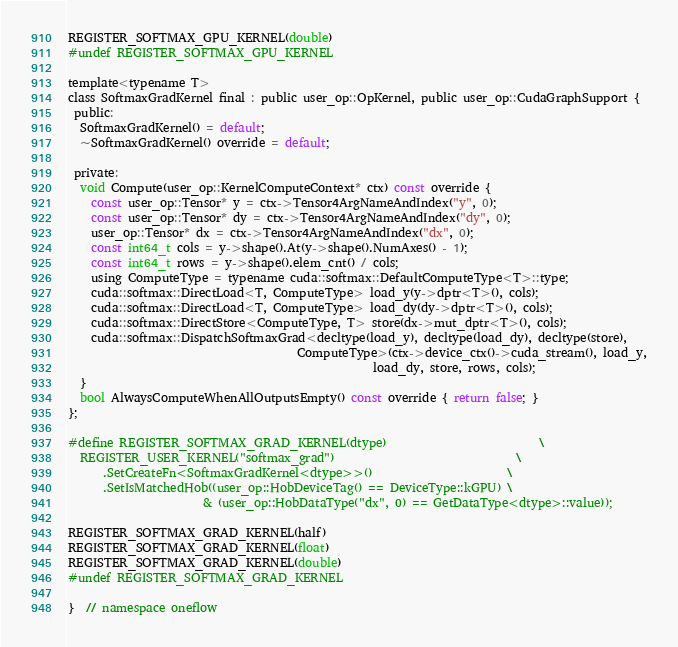Convert code to text. <code><loc_0><loc_0><loc_500><loc_500><_Cuda_>REGISTER_SOFTMAX_GPU_KERNEL(double)
#undef REGISTER_SOFTMAX_GPU_KERNEL

template<typename T>
class SoftmaxGradKernel final : public user_op::OpKernel, public user_op::CudaGraphSupport {
 public:
  SoftmaxGradKernel() = default;
  ~SoftmaxGradKernel() override = default;

 private:
  void Compute(user_op::KernelComputeContext* ctx) const override {
    const user_op::Tensor* y = ctx->Tensor4ArgNameAndIndex("y", 0);
    const user_op::Tensor* dy = ctx->Tensor4ArgNameAndIndex("dy", 0);
    user_op::Tensor* dx = ctx->Tensor4ArgNameAndIndex("dx", 0);
    const int64_t cols = y->shape().At(y->shape().NumAxes() - 1);
    const int64_t rows = y->shape().elem_cnt() / cols;
    using ComputeType = typename cuda::softmax::DefaultComputeType<T>::type;
    cuda::softmax::DirectLoad<T, ComputeType> load_y(y->dptr<T>(), cols);
    cuda::softmax::DirectLoad<T, ComputeType> load_dy(dy->dptr<T>(), cols);
    cuda::softmax::DirectStore<ComputeType, T> store(dx->mut_dptr<T>(), cols);
    cuda::softmax::DispatchSoftmaxGrad<decltype(load_y), decltype(load_dy), decltype(store),
                                       ComputeType>(ctx->device_ctx()->cuda_stream(), load_y,
                                                    load_dy, store, rows, cols);
  }
  bool AlwaysComputeWhenAllOutputsEmpty() const override { return false; }
};

#define REGISTER_SOFTMAX_GRAD_KERNEL(dtype)                          \
  REGISTER_USER_KERNEL("softmax_grad")                               \
      .SetCreateFn<SoftmaxGradKernel<dtype>>()                       \
      .SetIsMatchedHob((user_op::HobDeviceTag() == DeviceType::kGPU) \
                       & (user_op::HobDataType("dx", 0) == GetDataType<dtype>::value));

REGISTER_SOFTMAX_GRAD_KERNEL(half)
REGISTER_SOFTMAX_GRAD_KERNEL(float)
REGISTER_SOFTMAX_GRAD_KERNEL(double)
#undef REGISTER_SOFTMAX_GRAD_KERNEL

}  // namespace oneflow
</code> 